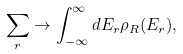<formula> <loc_0><loc_0><loc_500><loc_500>\sum _ { r } \rightarrow \int _ { - \infty } ^ { \infty } d E _ { r } \rho _ { R } ( E _ { r } ) ,</formula> 